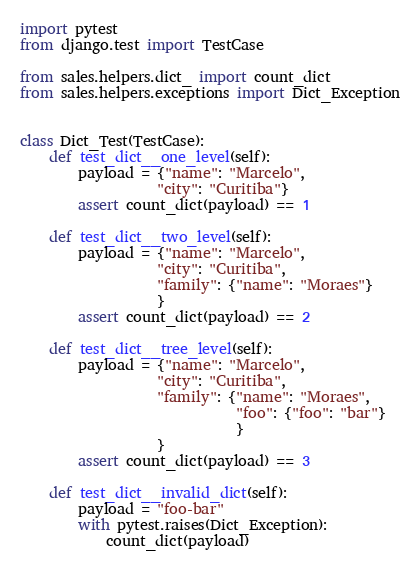<code> <loc_0><loc_0><loc_500><loc_500><_Python_>import pytest
from django.test import TestCase

from sales.helpers.dict_ import count_dict
from sales.helpers.exceptions import Dict_Exception


class Dict_Test(TestCase):
    def test_dict__one_level(self):
        payload = {"name": "Marcelo",
                   "city": "Curitiba"}
        assert count_dict(payload) == 1

    def test_dict__two_level(self):
        payload = {"name": "Marcelo",
                   "city": "Curitiba",
                   "family": {"name": "Moraes"}
                   }
        assert count_dict(payload) == 2

    def test_dict__tree_level(self):
        payload = {"name": "Marcelo",
                   "city": "Curitiba",
                   "family": {"name": "Moraes",
                              "foo": {"foo": "bar"}
                              }
                   }
        assert count_dict(payload) == 3

    def test_dict__invalid_dict(self):
        payload = "foo-bar"
        with pytest.raises(Dict_Exception):
            count_dict(payload)
</code> 